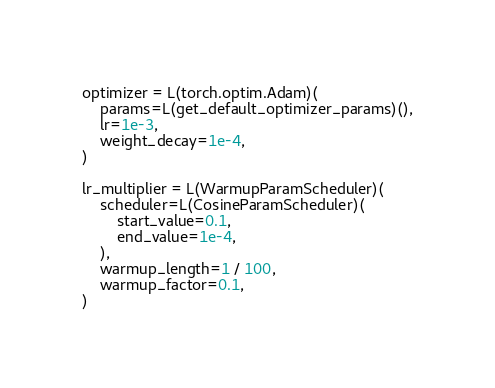<code> <loc_0><loc_0><loc_500><loc_500><_Python_>

optimizer = L(torch.optim.Adam)(
    params=L(get_default_optimizer_params)(),
    lr=1e-3,
    weight_decay=1e-4,
)

lr_multiplier = L(WarmupParamScheduler)(
    scheduler=L(CosineParamScheduler)(
        start_value=0.1,
        end_value=1e-4,
    ),
    warmup_length=1 / 100,
    warmup_factor=0.1,
)




</code> 